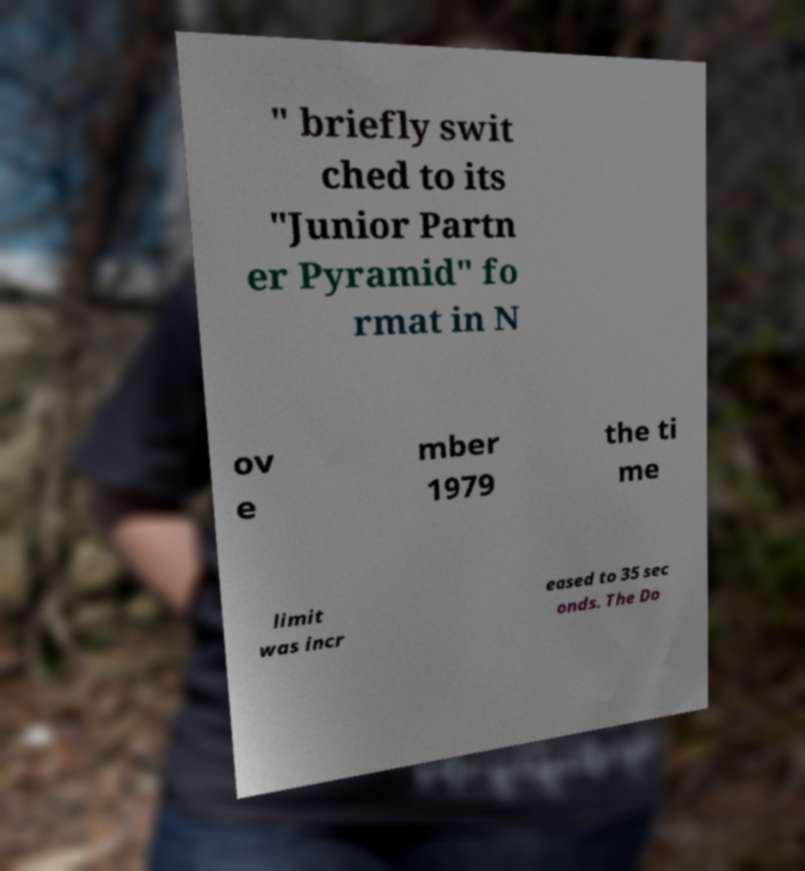Please read and relay the text visible in this image. What does it say? " briefly swit ched to its "Junior Partn er Pyramid" fo rmat in N ov e mber 1979 the ti me limit was incr eased to 35 sec onds. The Do 